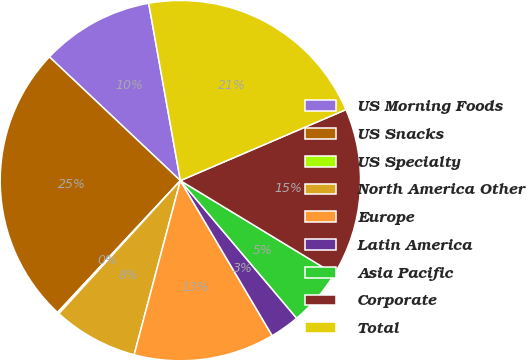<chart> <loc_0><loc_0><loc_500><loc_500><pie_chart><fcel>US Morning Foods<fcel>US Snacks<fcel>US Specialty<fcel>North America Other<fcel>Europe<fcel>Latin America<fcel>Asia Pacific<fcel>Corporate<fcel>Total<nl><fcel>10.14%<fcel>25.11%<fcel>0.16%<fcel>7.65%<fcel>12.64%<fcel>2.66%<fcel>5.15%<fcel>15.13%<fcel>21.37%<nl></chart> 